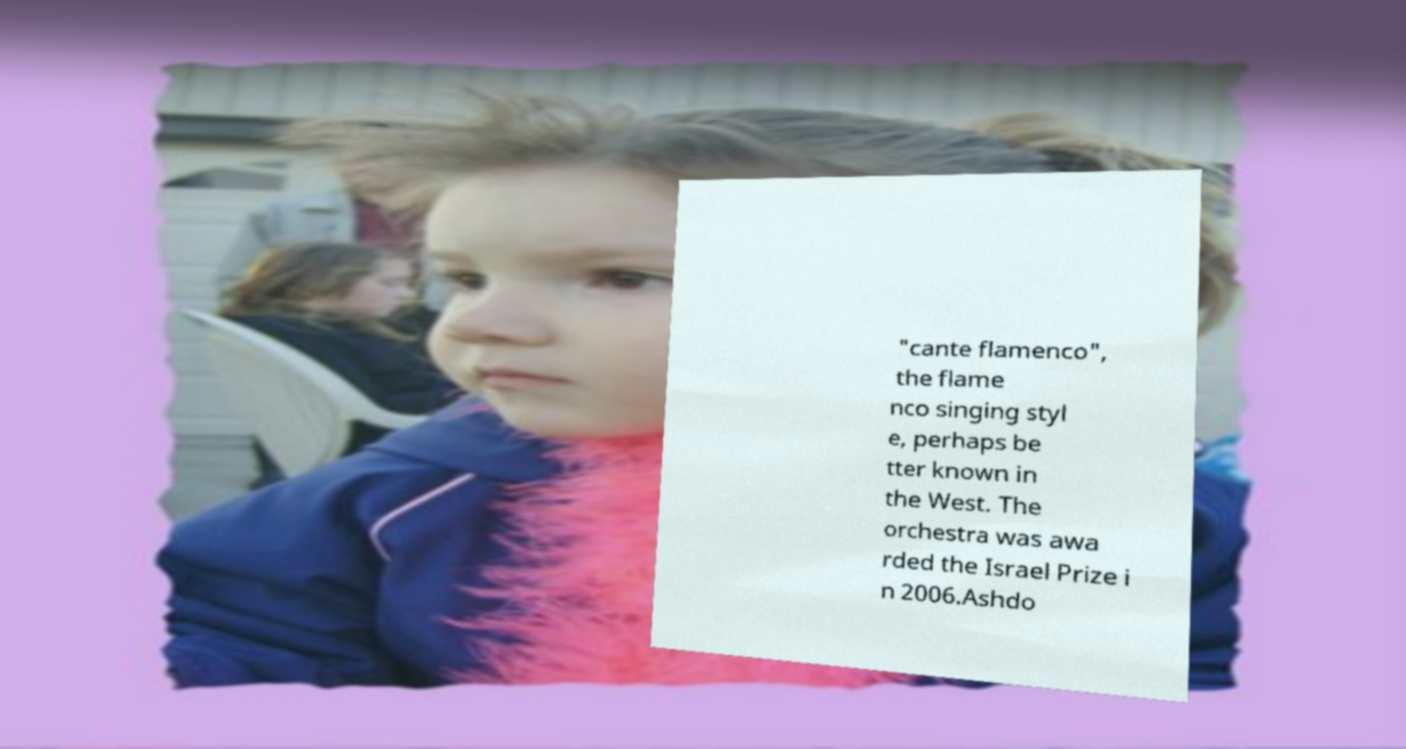There's text embedded in this image that I need extracted. Can you transcribe it verbatim? "cante flamenco", the flame nco singing styl e, perhaps be tter known in the West. The orchestra was awa rded the Israel Prize i n 2006.Ashdo 